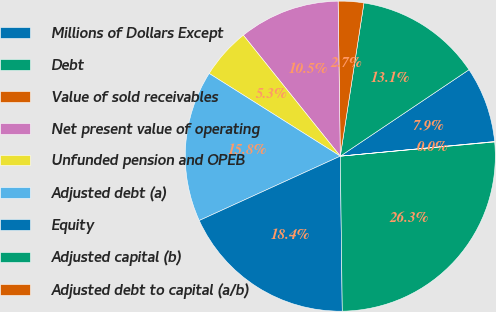<chart> <loc_0><loc_0><loc_500><loc_500><pie_chart><fcel>Millions of Dollars Except<fcel>Debt<fcel>Value of sold receivables<fcel>Net present value of operating<fcel>Unfunded pension and OPEB<fcel>Adjusted debt (a)<fcel>Equity<fcel>Adjusted capital (b)<fcel>Adjusted debt to capital (a/b)<nl><fcel>7.91%<fcel>13.15%<fcel>2.66%<fcel>10.53%<fcel>5.29%<fcel>15.77%<fcel>18.39%<fcel>26.26%<fcel>0.04%<nl></chart> 